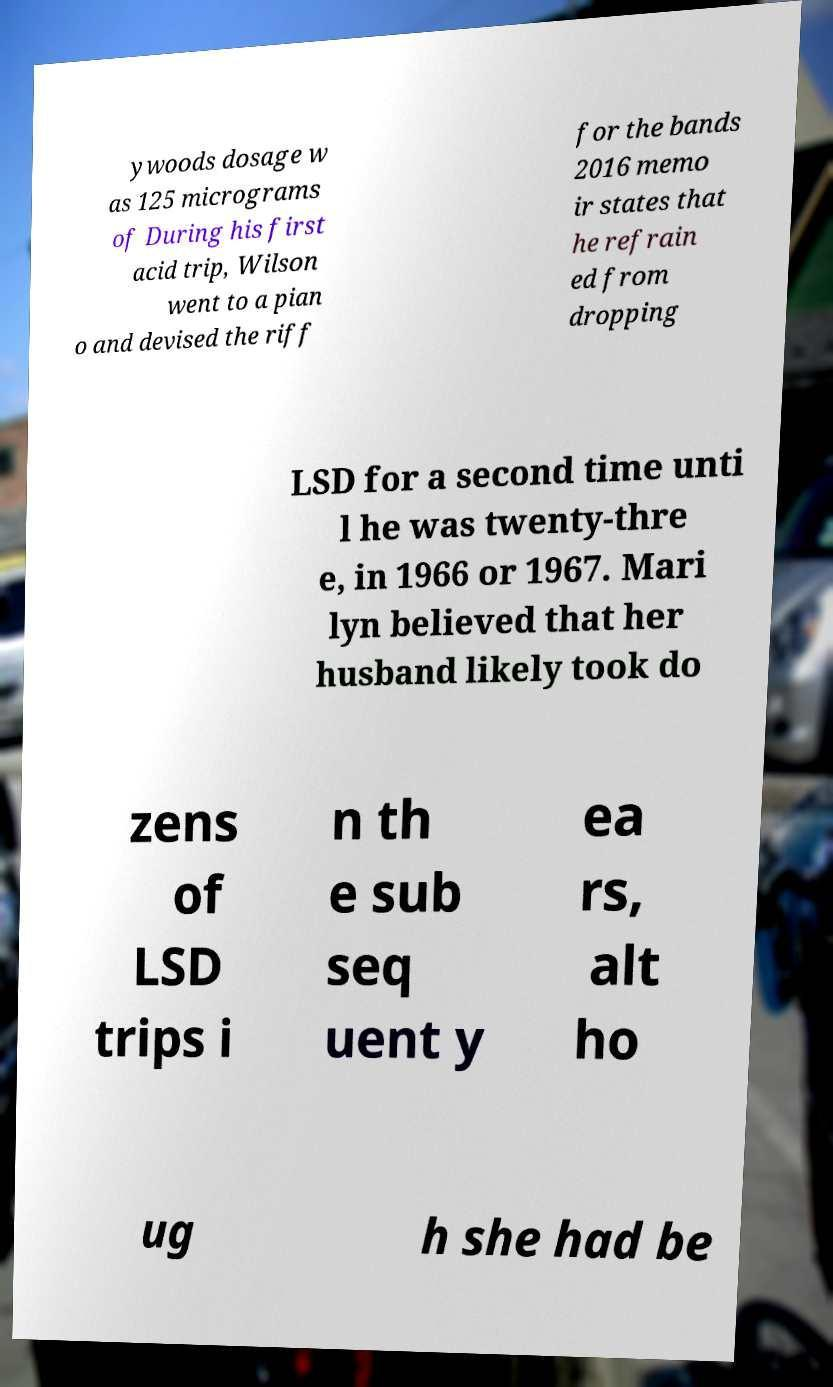Please read and relay the text visible in this image. What does it say? ywoods dosage w as 125 micrograms of During his first acid trip, Wilson went to a pian o and devised the riff for the bands 2016 memo ir states that he refrain ed from dropping LSD for a second time unti l he was twenty-thre e, in 1966 or 1967. Mari lyn believed that her husband likely took do zens of LSD trips i n th e sub seq uent y ea rs, alt ho ug h she had be 